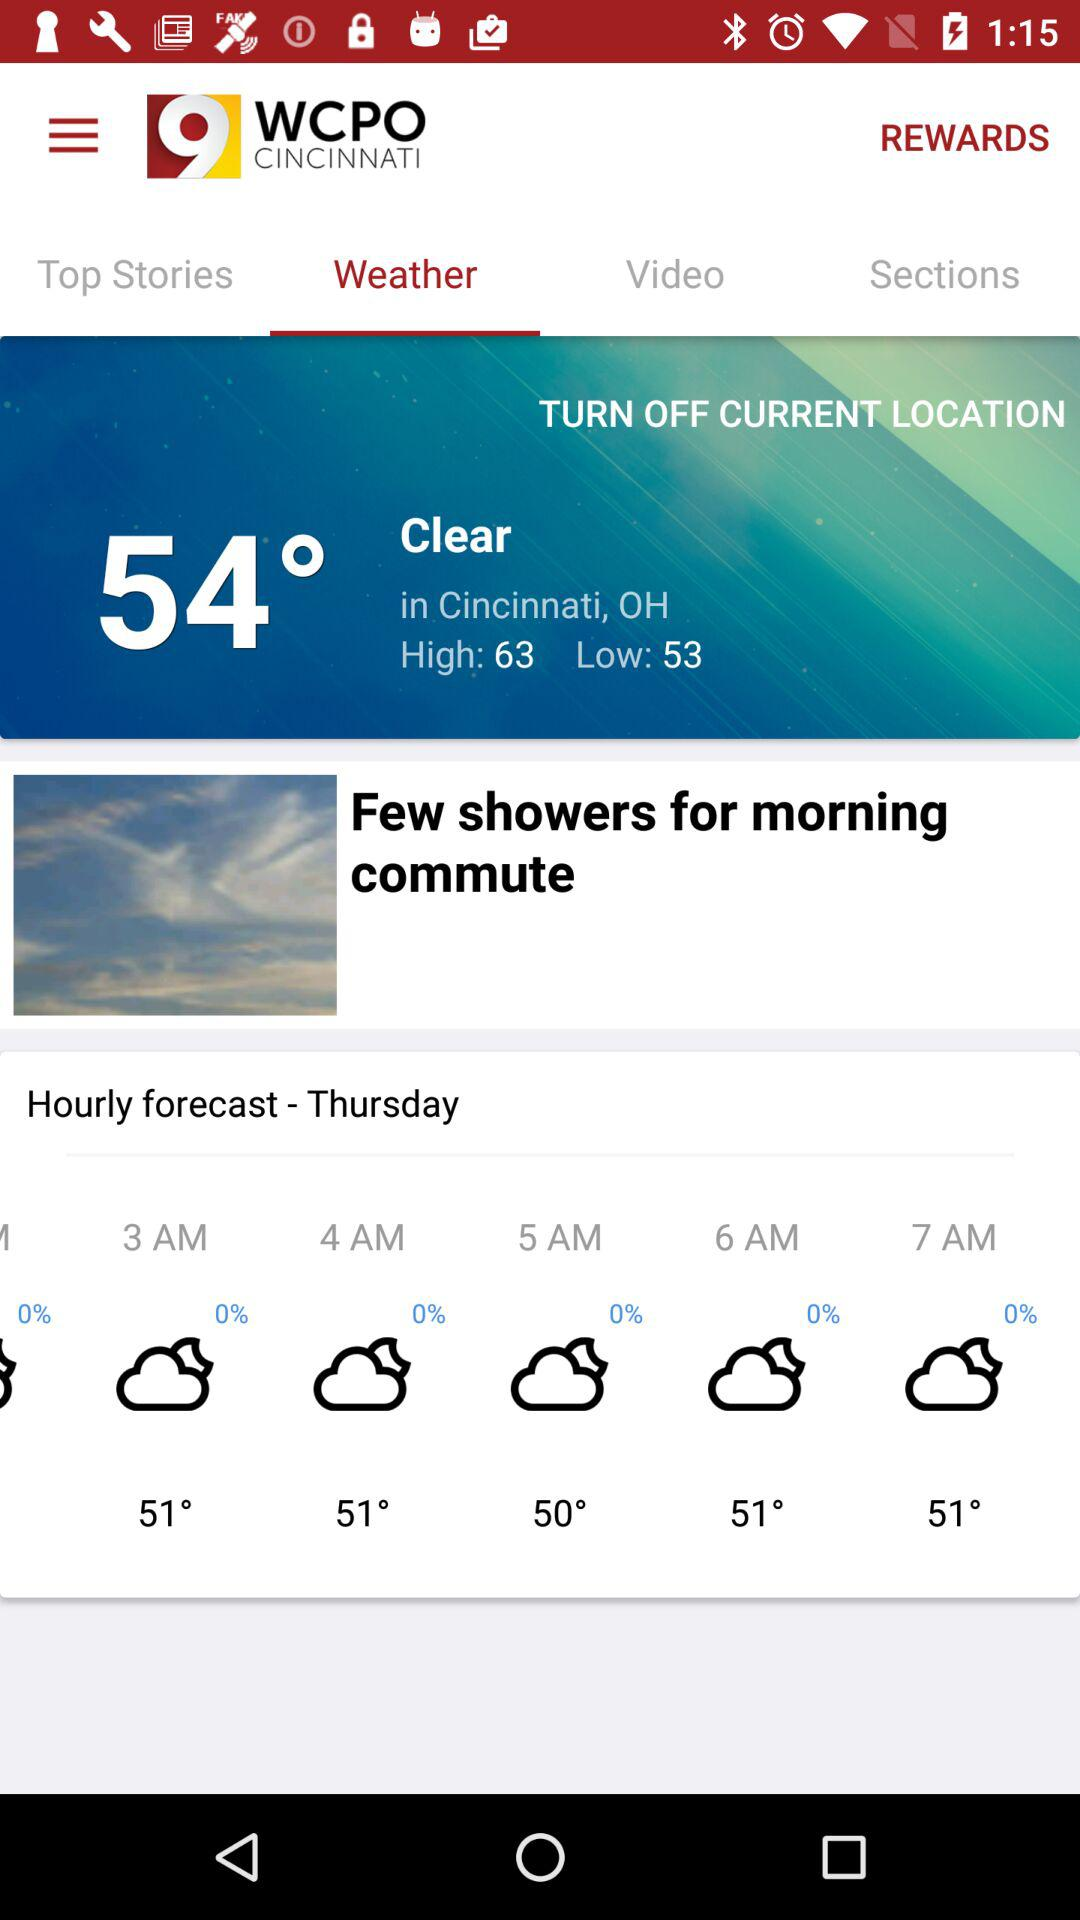What's the current location? The current location is Cincinnati, OH. 